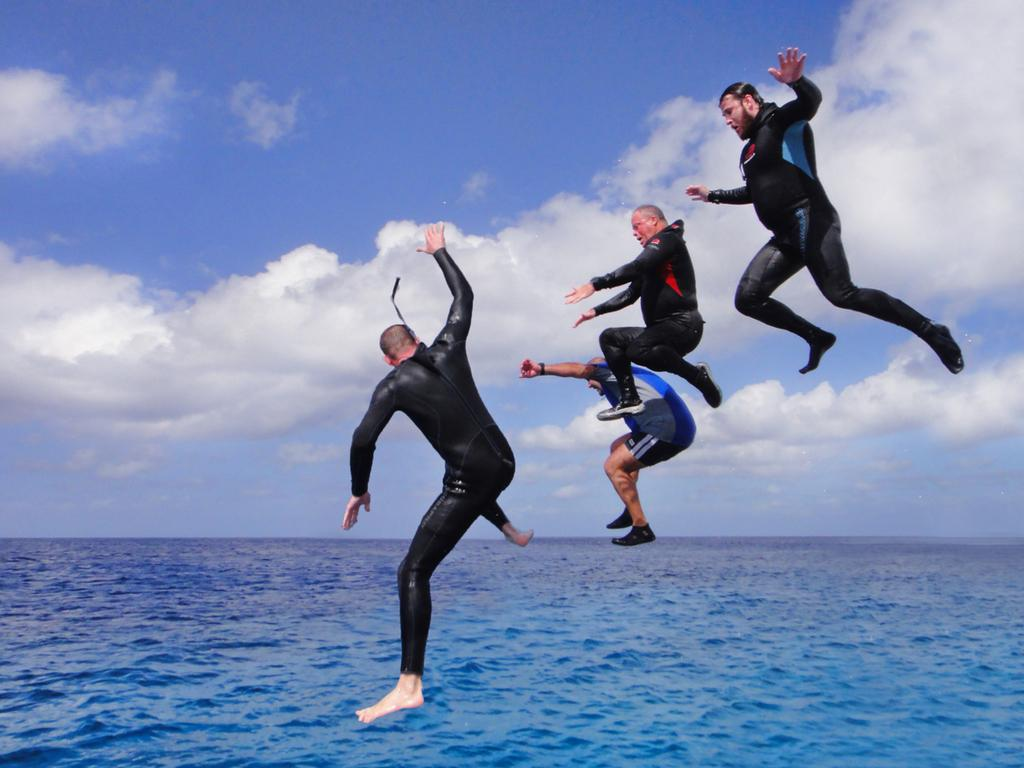How many people are in the image? There are four men in the image. What are the men wearing? The men are wearing black color dresses. What are the men doing in the image? The men are jumping into the water. What type of water can be seen in the image? The water appears to be an ocean. What is visible at the top of the image? The sky is visible at the top of the image. What can be seen in the sky? Clouds are present in the sky. What type of thing is the men using to wash their clothes in the image? There is no indication in the image that the men are washing their clothes, and no such object is present. 